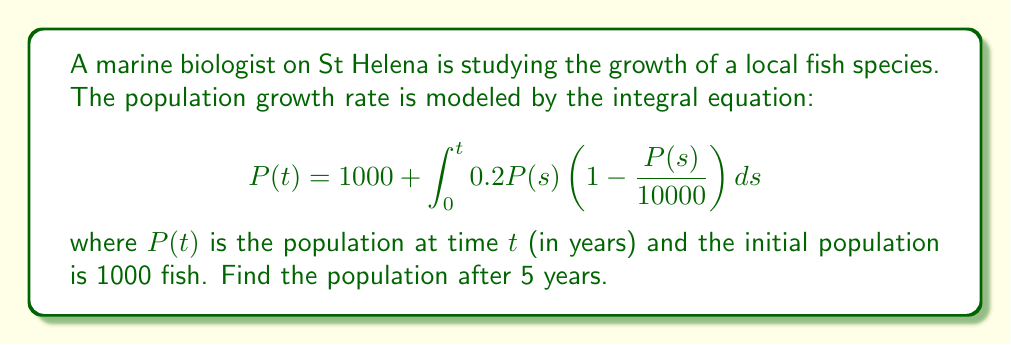Give your solution to this math problem. To solve this integral equation, we'll use the following steps:

1) First, we recognize this as a Volterra integral equation of the second kind.

2) We can solve this numerically using Picard iteration. Let's start with the initial guess $P_0(t) = 1000$ (the initial population).

3) We then use the iterative formula:

   $$P_{n+1}(t) = 1000 + \int_0^t 0.2P_n(s)(1 - \frac{P_n(s)}{10000})ds$$

4) Let's perform a few iterations:

   For $P_1(t)$:
   $$P_1(t) = 1000 + \int_0^t 0.2 \cdot 1000(1 - \frac{1000}{10000})ds = 1000 + 180t$$

   For $P_2(t)$:
   $$P_2(t) = 1000 + \int_0^t 0.2(1000 + 180s)(1 - \frac{1000 + 180s}{10000})ds$$
   
   This gives us:
   $$P_2(t) = 1000 + 180t - 1.62t^2$$

5) We could continue this process, but let's stop here for simplicity.

6) To find the population after 5 years, we substitute $t = 5$ into our last approximation:

   $$P(5) \approx 1000 + 180(5) - 1.62(5^2) = 1859.5$$

7) Rounding to the nearest whole number (as we can't have fractional fish), we get 1860 fish.
Answer: 1860 fish 